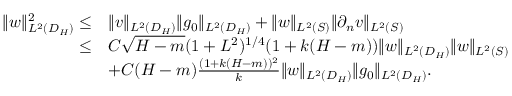Convert formula to latex. <formula><loc_0><loc_0><loc_500><loc_500>\begin{array} { r l } { \| w \| _ { L ^ { 2 } ( D _ { H } ) } ^ { 2 } \leq } & { \| v \| _ { L ^ { 2 } ( D _ { H } ) } \| g _ { 0 } \| _ { L ^ { 2 } ( D _ { H } ) } + \| w \| _ { L ^ { 2 } ( S ) } \| \partial _ { n } v \| _ { L ^ { 2 } ( S ) } } \\ { \leq } & { C \sqrt { H - m } ( 1 + L ^ { 2 } ) ^ { 1 / 4 } ( 1 + k ( H - m ) ) \| w \| _ { L ^ { 2 } ( D _ { H } ) } \| w \| _ { L ^ { 2 } ( S ) } } \\ & { + C ( H - m ) \frac { ( 1 + k ( H - m ) ) ^ { 2 } } { k } \| w \| _ { L ^ { 2 } ( D _ { H } ) } \| g _ { 0 } \| _ { L ^ { 2 } ( D _ { H } ) } . } \end{array}</formula> 